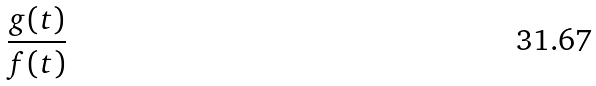Convert formula to latex. <formula><loc_0><loc_0><loc_500><loc_500>\frac { g ( t ) } { f ( t ) }</formula> 